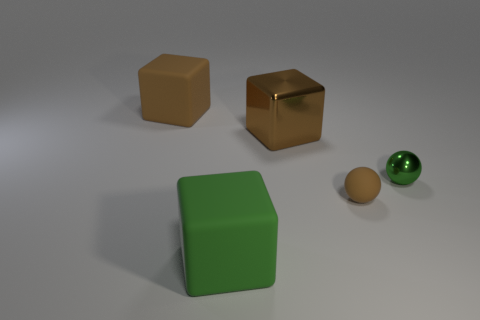Is there any other thing that has the same material as the large green thing?
Provide a succinct answer. Yes. What number of tiny spheres are to the left of the sphere behind the tiny thing that is left of the small metal ball?
Your answer should be compact. 1. What number of other things are the same material as the large green object?
Offer a very short reply. 2. There is a brown ball that is the same size as the green ball; what is its material?
Ensure brevity in your answer.  Rubber. There is a object behind the big brown metallic block; is its color the same as the big thing in front of the green ball?
Make the answer very short. No. Is there a tiny yellow object that has the same shape as the tiny brown rubber thing?
Offer a terse response. No. What shape is the brown object that is the same size as the green metal thing?
Make the answer very short. Sphere. What number of large objects are the same color as the small rubber ball?
Offer a terse response. 2. There is a brown thing left of the green cube; what is its size?
Your answer should be very brief. Large. What number of blocks have the same size as the brown metal object?
Your answer should be very brief. 2. 